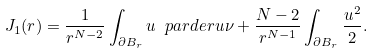<formula> <loc_0><loc_0><loc_500><loc_500>J _ { 1 } ( r ) = \frac { 1 } { r ^ { N - 2 } } \int _ { \partial B _ { r } } u \ p a r d e r { u } { \nu } + \frac { N - 2 } { r ^ { N - 1 } } \int _ { \partial B _ { r } } \frac { u ^ { 2 } } { 2 } .</formula> 